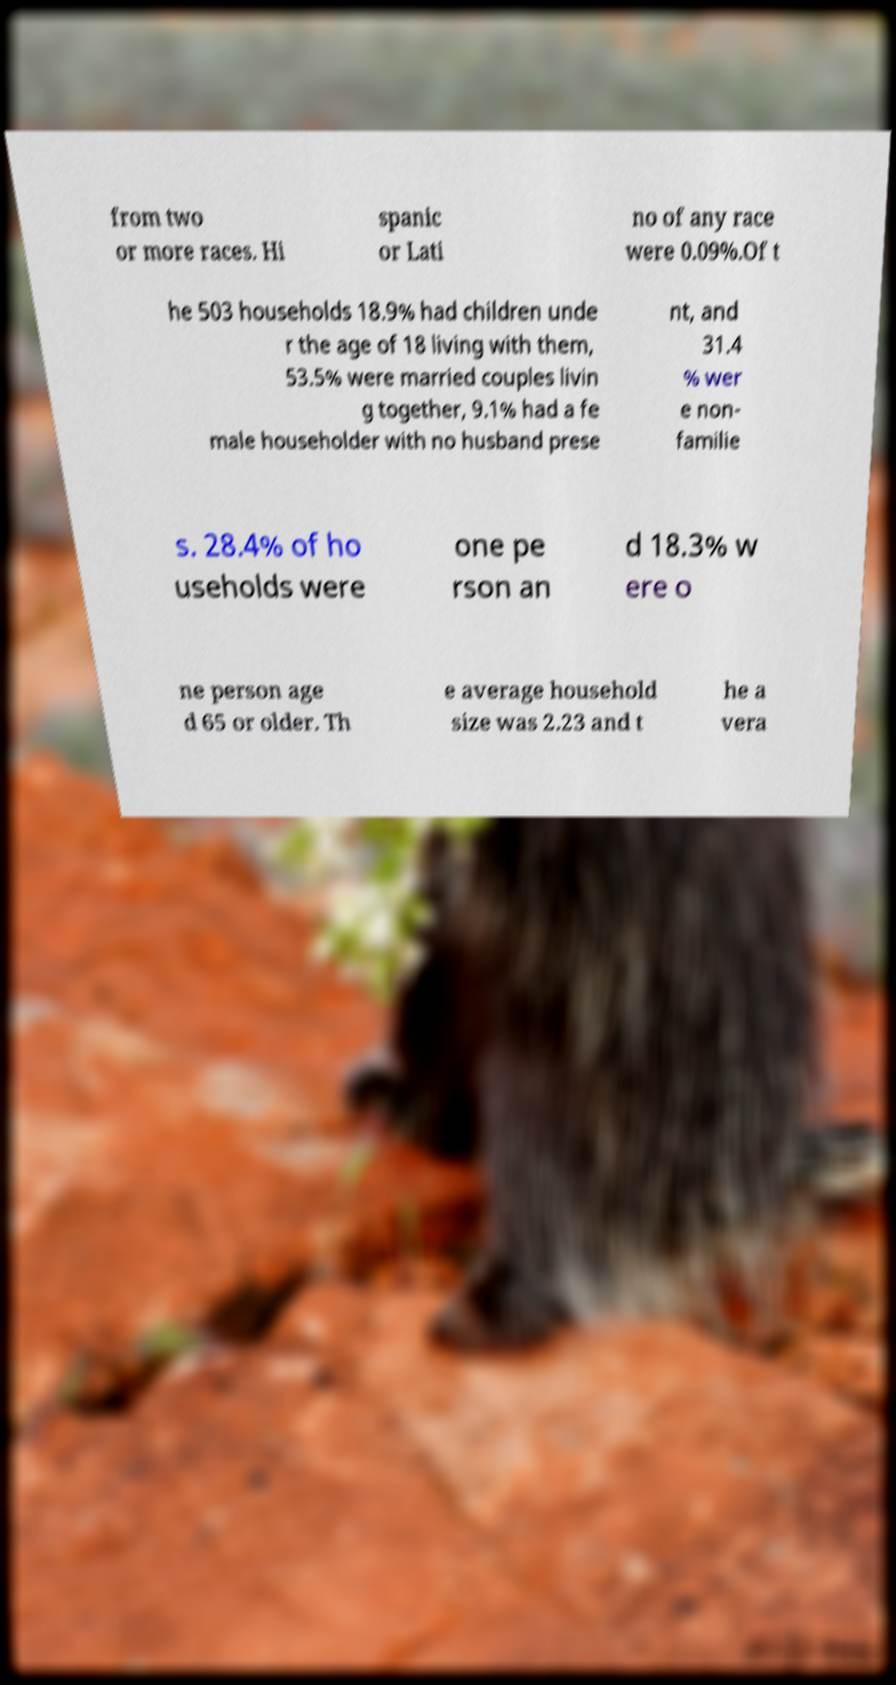Can you read and provide the text displayed in the image?This photo seems to have some interesting text. Can you extract and type it out for me? from two or more races. Hi spanic or Lati no of any race were 0.09%.Of t he 503 households 18.9% had children unde r the age of 18 living with them, 53.5% were married couples livin g together, 9.1% had a fe male householder with no husband prese nt, and 31.4 % wer e non- familie s. 28.4% of ho useholds were one pe rson an d 18.3% w ere o ne person age d 65 or older. Th e average household size was 2.23 and t he a vera 